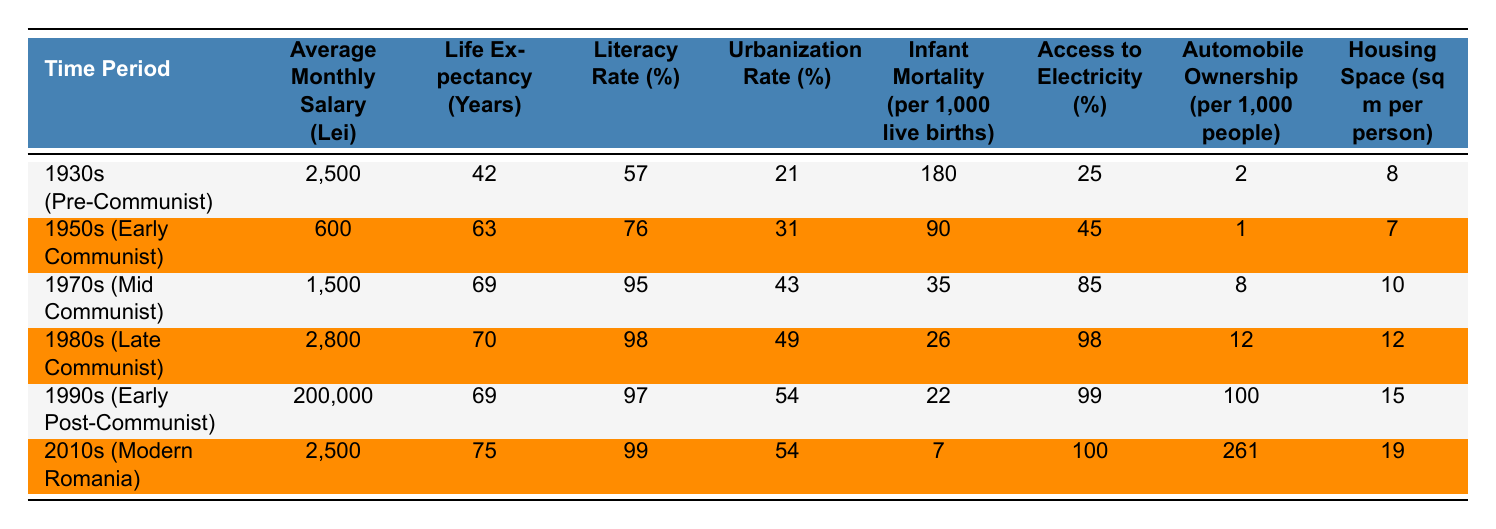What was the average monthly salary in the 1980s? In the table, under the "Average Monthly Salary (Lei)" column for the 1980s (Late Communist), the value is listed as 2,800 Lei.
Answer: 2,800 Lei Which time period had the highest literacy rate? Looking at the "Literacy Rate (%)" column, the 1980s (Late Communist) has the highest value at 98%.
Answer: 1980s (Late Communist) How did life expectancy change from the 1950s to the 2010s? The life expectancy in the 1950s was 63 years, and in the 2010s it was 75 years. To find the change, subtract 63 from 75, which gives a difference of 12 years.
Answer: It increased by 12 years What was the percentage of access to electricity in the 1970s? In the "Access to Electricity (%)" column for the 1970s (Mid Communist), the table indicates 85% access.
Answer: 85% Did the urbanization rate increase or decrease from the 1930s to the 1990s? The urbanization rate in the 1930s was 21%, whereas in the 1990s it was 54%. This represents an increase of 33 percentage points.
Answer: It increased Which time period had the highest rate of infant mortality? The "Infant Mortality (per 1,000 live births)" column shows the 1930s (Pre-Communist) with a high value of 180 per 1,000 live births, the highest among all periods listed.
Answer: 1930s (Pre-Communist) What is the average housing space per person from the 1950s to the 1990s? The housing spaces per person for the 1950s, 1970s, and 1990s are 7, 10, and 15 sq m respectively. Adding these gives 32 sq m, and dividing by 3 (the number of decades) results in an average of about 10.67 sq m.
Answer: Approximately 10.67 sq m In which decade did automobile ownership first exceed 10 per 1,000 people? By examining the "Automobile Ownership (per 1,000 people)" column, we see that only the 1990s exceeds 10, with 100 per 1,000 people.
Answer: In the 1990s What was the change in the urbanization rate from the 1980s to the 2010s? The urbanization rates were 49% in the 1980s and 54% in the 2010s. The change is 54% - 49% = 5 percentage points.
Answer: It increased by 5 percentage points Was the average monthly salary higher in the 1990s or the 2010s? The table indicates an average monthly salary of 200,000 Lei in the 1990s, compared to 2,500 Lei in the 2010s. Thus, the 1990s had a higher average.
Answer: Higher in the 1990s Is it true that life expectancy in the Late Communist era was lower than in Modern Romania? In the Late Communist era (1980s), life expectancy was 70 years, while it was 75 years in Modern Romania (2010s). Therefore, this statement is false.
Answer: No, it is false 